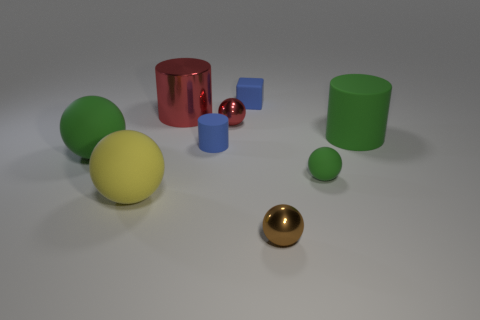Is the small rubber ball the same color as the large rubber cylinder?
Keep it short and to the point. Yes. There is a metal object that is to the right of the big red shiny thing and to the left of the small brown object; what size is it?
Your response must be concise. Small. How many red cylinders are made of the same material as the small brown ball?
Keep it short and to the point. 1. What color is the cube that is the same material as the big yellow ball?
Your answer should be very brief. Blue. Does the big cylinder on the right side of the red sphere have the same color as the small matte sphere?
Make the answer very short. Yes. What is the sphere on the right side of the tiny brown metal object made of?
Make the answer very short. Rubber. Are there an equal number of tiny matte objects that are behind the big green cylinder and large metal objects?
Offer a very short reply. Yes. How many other small blocks have the same color as the rubber cube?
Ensure brevity in your answer.  0. The big matte thing that is the same shape as the big metallic thing is what color?
Provide a succinct answer. Green. Is the size of the blue matte cylinder the same as the shiny cylinder?
Offer a terse response. No. 